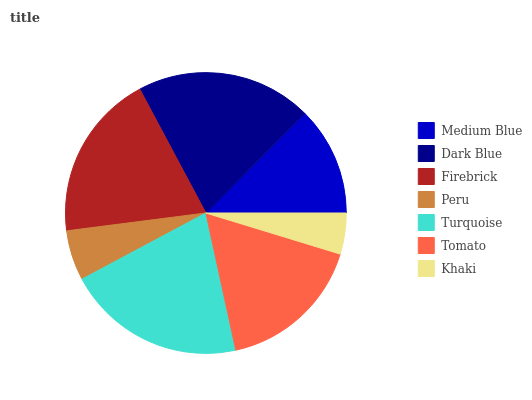Is Khaki the minimum?
Answer yes or no. Yes. Is Turquoise the maximum?
Answer yes or no. Yes. Is Dark Blue the minimum?
Answer yes or no. No. Is Dark Blue the maximum?
Answer yes or no. No. Is Dark Blue greater than Medium Blue?
Answer yes or no. Yes. Is Medium Blue less than Dark Blue?
Answer yes or no. Yes. Is Medium Blue greater than Dark Blue?
Answer yes or no. No. Is Dark Blue less than Medium Blue?
Answer yes or no. No. Is Tomato the high median?
Answer yes or no. Yes. Is Tomato the low median?
Answer yes or no. Yes. Is Firebrick the high median?
Answer yes or no. No. Is Peru the low median?
Answer yes or no. No. 